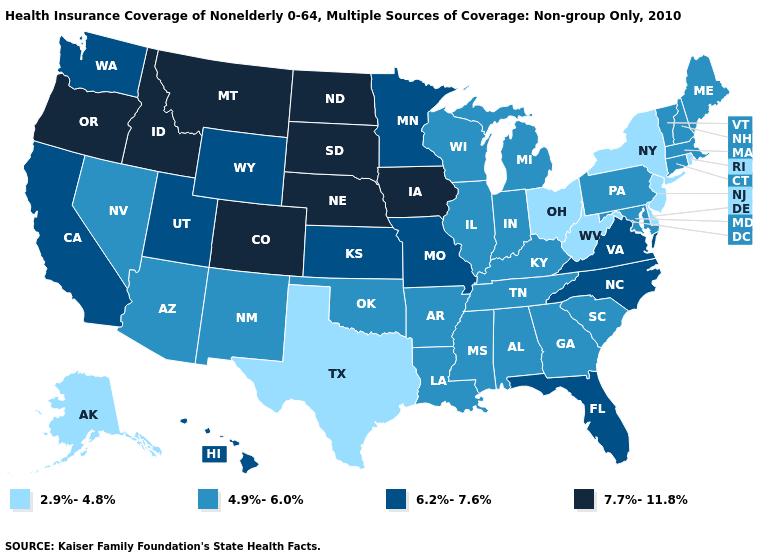Which states have the lowest value in the USA?
Answer briefly. Alaska, Delaware, New Jersey, New York, Ohio, Rhode Island, Texas, West Virginia. Does North Carolina have the lowest value in the USA?
Be succinct. No. Among the states that border Kentucky , does Virginia have the lowest value?
Concise answer only. No. What is the value of Colorado?
Be succinct. 7.7%-11.8%. What is the value of Colorado?
Be succinct. 7.7%-11.8%. What is the lowest value in the USA?
Be succinct. 2.9%-4.8%. Name the states that have a value in the range 4.9%-6.0%?
Concise answer only. Alabama, Arizona, Arkansas, Connecticut, Georgia, Illinois, Indiana, Kentucky, Louisiana, Maine, Maryland, Massachusetts, Michigan, Mississippi, Nevada, New Hampshire, New Mexico, Oklahoma, Pennsylvania, South Carolina, Tennessee, Vermont, Wisconsin. What is the value of Arizona?
Give a very brief answer. 4.9%-6.0%. Name the states that have a value in the range 2.9%-4.8%?
Write a very short answer. Alaska, Delaware, New Jersey, New York, Ohio, Rhode Island, Texas, West Virginia. Among the states that border North Dakota , does South Dakota have the highest value?
Answer briefly. Yes. Which states have the lowest value in the West?
Give a very brief answer. Alaska. How many symbols are there in the legend?
Answer briefly. 4. Does Oregon have the highest value in the USA?
Concise answer only. Yes. Does the map have missing data?
Concise answer only. No. Name the states that have a value in the range 4.9%-6.0%?
Keep it brief. Alabama, Arizona, Arkansas, Connecticut, Georgia, Illinois, Indiana, Kentucky, Louisiana, Maine, Maryland, Massachusetts, Michigan, Mississippi, Nevada, New Hampshire, New Mexico, Oklahoma, Pennsylvania, South Carolina, Tennessee, Vermont, Wisconsin. 